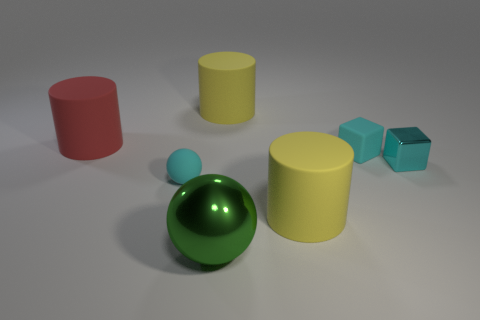How many other things are the same shape as the big green shiny object? There is one object that shares the same spherical shape as the big green shiny sphere — it is the smaller blue sphere. 